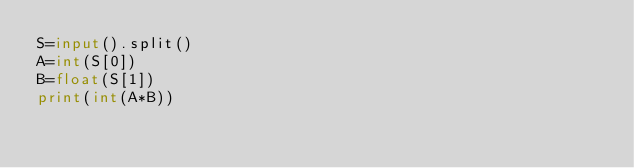<code> <loc_0><loc_0><loc_500><loc_500><_Python_>S=input().split()
A=int(S[0])
B=float(S[1])
print(int(A*B))</code> 